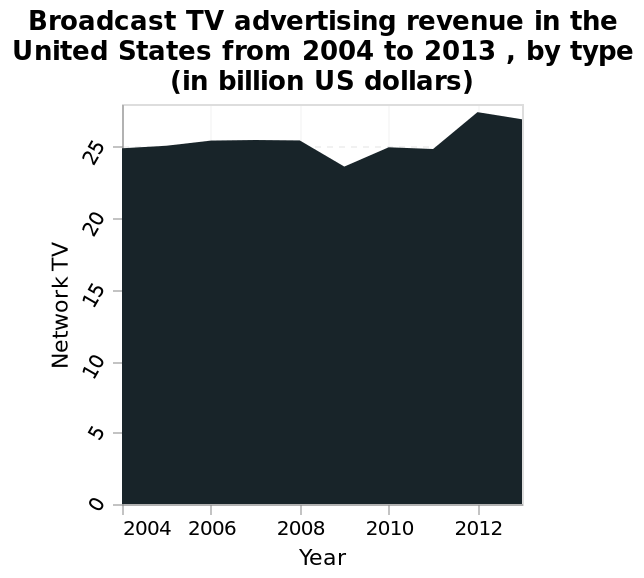<image>
Describe the following image in detail Broadcast TV advertising revenue in the United States from 2004 to 2013 , by type (in billion US dollars) is a area graph. Along the x-axis, Year is measured with a linear scale with a minimum of 2004 and a maximum of 2012. The y-axis shows Network TV. 